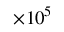<formula> <loc_0><loc_0><loc_500><loc_500>\times 1 0 ^ { 5 }</formula> 